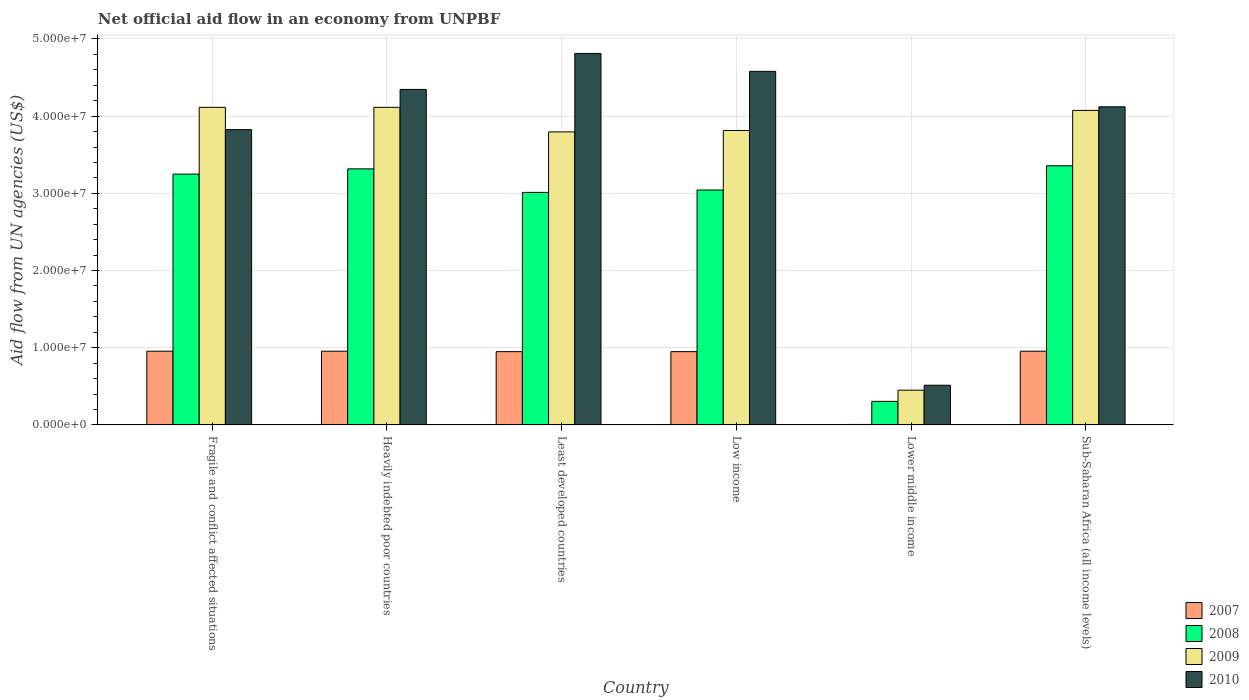How many groups of bars are there?
Your answer should be compact. 6. How many bars are there on the 1st tick from the left?
Make the answer very short. 4. How many bars are there on the 2nd tick from the right?
Your response must be concise. 4. What is the label of the 6th group of bars from the left?
Provide a short and direct response. Sub-Saharan Africa (all income levels). In how many cases, is the number of bars for a given country not equal to the number of legend labels?
Give a very brief answer. 0. What is the net official aid flow in 2009 in Sub-Saharan Africa (all income levels)?
Make the answer very short. 4.07e+07. Across all countries, what is the maximum net official aid flow in 2008?
Make the answer very short. 3.36e+07. Across all countries, what is the minimum net official aid flow in 2010?
Your response must be concise. 5.14e+06. In which country was the net official aid flow in 2010 maximum?
Ensure brevity in your answer.  Least developed countries. In which country was the net official aid flow in 2010 minimum?
Ensure brevity in your answer.  Lower middle income. What is the total net official aid flow in 2007 in the graph?
Offer a terse response. 4.77e+07. What is the difference between the net official aid flow in 2010 in Fragile and conflict affected situations and that in Sub-Saharan Africa (all income levels)?
Keep it short and to the point. -2.96e+06. What is the difference between the net official aid flow in 2009 in Low income and the net official aid flow in 2008 in Heavily indebted poor countries?
Provide a short and direct response. 4.97e+06. What is the average net official aid flow in 2008 per country?
Offer a very short reply. 2.71e+07. What is the difference between the net official aid flow of/in 2008 and net official aid flow of/in 2009 in Low income?
Keep it short and to the point. -7.71e+06. In how many countries, is the net official aid flow in 2008 greater than 38000000 US$?
Provide a succinct answer. 0. What is the ratio of the net official aid flow in 2009 in Least developed countries to that in Sub-Saharan Africa (all income levels)?
Keep it short and to the point. 0.93. Is the net official aid flow in 2008 in Least developed countries less than that in Sub-Saharan Africa (all income levels)?
Provide a short and direct response. Yes. What is the difference between the highest and the second highest net official aid flow in 2009?
Provide a short and direct response. 4.00e+05. What is the difference between the highest and the lowest net official aid flow in 2008?
Offer a terse response. 3.05e+07. In how many countries, is the net official aid flow in 2008 greater than the average net official aid flow in 2008 taken over all countries?
Ensure brevity in your answer.  5. Is the sum of the net official aid flow in 2007 in Low income and Sub-Saharan Africa (all income levels) greater than the maximum net official aid flow in 2010 across all countries?
Make the answer very short. No. Is it the case that in every country, the sum of the net official aid flow in 2008 and net official aid flow in 2007 is greater than the sum of net official aid flow in 2009 and net official aid flow in 2010?
Keep it short and to the point. No. What does the 1st bar from the left in Sub-Saharan Africa (all income levels) represents?
Give a very brief answer. 2007. Is it the case that in every country, the sum of the net official aid flow in 2010 and net official aid flow in 2007 is greater than the net official aid flow in 2008?
Keep it short and to the point. Yes. How many bars are there?
Make the answer very short. 24. What is the difference between two consecutive major ticks on the Y-axis?
Offer a very short reply. 1.00e+07. Are the values on the major ticks of Y-axis written in scientific E-notation?
Give a very brief answer. Yes. How many legend labels are there?
Give a very brief answer. 4. What is the title of the graph?
Make the answer very short. Net official aid flow in an economy from UNPBF. Does "1994" appear as one of the legend labels in the graph?
Keep it short and to the point. No. What is the label or title of the X-axis?
Your answer should be compact. Country. What is the label or title of the Y-axis?
Ensure brevity in your answer.  Aid flow from UN agencies (US$). What is the Aid flow from UN agencies (US$) of 2007 in Fragile and conflict affected situations?
Your response must be concise. 9.55e+06. What is the Aid flow from UN agencies (US$) of 2008 in Fragile and conflict affected situations?
Keep it short and to the point. 3.25e+07. What is the Aid flow from UN agencies (US$) of 2009 in Fragile and conflict affected situations?
Provide a short and direct response. 4.11e+07. What is the Aid flow from UN agencies (US$) in 2010 in Fragile and conflict affected situations?
Offer a terse response. 3.82e+07. What is the Aid flow from UN agencies (US$) of 2007 in Heavily indebted poor countries?
Offer a very short reply. 9.55e+06. What is the Aid flow from UN agencies (US$) in 2008 in Heavily indebted poor countries?
Offer a terse response. 3.32e+07. What is the Aid flow from UN agencies (US$) in 2009 in Heavily indebted poor countries?
Offer a terse response. 4.11e+07. What is the Aid flow from UN agencies (US$) of 2010 in Heavily indebted poor countries?
Keep it short and to the point. 4.35e+07. What is the Aid flow from UN agencies (US$) of 2007 in Least developed countries?
Offer a terse response. 9.49e+06. What is the Aid flow from UN agencies (US$) of 2008 in Least developed countries?
Your answer should be very brief. 3.01e+07. What is the Aid flow from UN agencies (US$) of 2009 in Least developed countries?
Keep it short and to the point. 3.80e+07. What is the Aid flow from UN agencies (US$) in 2010 in Least developed countries?
Your answer should be very brief. 4.81e+07. What is the Aid flow from UN agencies (US$) of 2007 in Low income?
Your answer should be compact. 9.49e+06. What is the Aid flow from UN agencies (US$) in 2008 in Low income?
Offer a very short reply. 3.04e+07. What is the Aid flow from UN agencies (US$) in 2009 in Low income?
Ensure brevity in your answer.  3.81e+07. What is the Aid flow from UN agencies (US$) in 2010 in Low income?
Give a very brief answer. 4.58e+07. What is the Aid flow from UN agencies (US$) in 2008 in Lower middle income?
Your answer should be compact. 3.05e+06. What is the Aid flow from UN agencies (US$) in 2009 in Lower middle income?
Provide a succinct answer. 4.50e+06. What is the Aid flow from UN agencies (US$) in 2010 in Lower middle income?
Offer a very short reply. 5.14e+06. What is the Aid flow from UN agencies (US$) of 2007 in Sub-Saharan Africa (all income levels)?
Your answer should be very brief. 9.55e+06. What is the Aid flow from UN agencies (US$) of 2008 in Sub-Saharan Africa (all income levels)?
Offer a very short reply. 3.36e+07. What is the Aid flow from UN agencies (US$) of 2009 in Sub-Saharan Africa (all income levels)?
Your answer should be very brief. 4.07e+07. What is the Aid flow from UN agencies (US$) in 2010 in Sub-Saharan Africa (all income levels)?
Provide a short and direct response. 4.12e+07. Across all countries, what is the maximum Aid flow from UN agencies (US$) in 2007?
Your response must be concise. 9.55e+06. Across all countries, what is the maximum Aid flow from UN agencies (US$) in 2008?
Offer a very short reply. 3.36e+07. Across all countries, what is the maximum Aid flow from UN agencies (US$) of 2009?
Offer a terse response. 4.11e+07. Across all countries, what is the maximum Aid flow from UN agencies (US$) of 2010?
Keep it short and to the point. 4.81e+07. Across all countries, what is the minimum Aid flow from UN agencies (US$) in 2008?
Keep it short and to the point. 3.05e+06. Across all countries, what is the minimum Aid flow from UN agencies (US$) of 2009?
Provide a succinct answer. 4.50e+06. Across all countries, what is the minimum Aid flow from UN agencies (US$) of 2010?
Keep it short and to the point. 5.14e+06. What is the total Aid flow from UN agencies (US$) in 2007 in the graph?
Your response must be concise. 4.77e+07. What is the total Aid flow from UN agencies (US$) of 2008 in the graph?
Ensure brevity in your answer.  1.63e+08. What is the total Aid flow from UN agencies (US$) of 2009 in the graph?
Your answer should be very brief. 2.04e+08. What is the total Aid flow from UN agencies (US$) in 2010 in the graph?
Your answer should be very brief. 2.22e+08. What is the difference between the Aid flow from UN agencies (US$) in 2007 in Fragile and conflict affected situations and that in Heavily indebted poor countries?
Your response must be concise. 0. What is the difference between the Aid flow from UN agencies (US$) in 2008 in Fragile and conflict affected situations and that in Heavily indebted poor countries?
Offer a very short reply. -6.80e+05. What is the difference between the Aid flow from UN agencies (US$) of 2009 in Fragile and conflict affected situations and that in Heavily indebted poor countries?
Ensure brevity in your answer.  0. What is the difference between the Aid flow from UN agencies (US$) in 2010 in Fragile and conflict affected situations and that in Heavily indebted poor countries?
Your answer should be very brief. -5.21e+06. What is the difference between the Aid flow from UN agencies (US$) in 2007 in Fragile and conflict affected situations and that in Least developed countries?
Ensure brevity in your answer.  6.00e+04. What is the difference between the Aid flow from UN agencies (US$) of 2008 in Fragile and conflict affected situations and that in Least developed countries?
Offer a very short reply. 2.37e+06. What is the difference between the Aid flow from UN agencies (US$) of 2009 in Fragile and conflict affected situations and that in Least developed countries?
Your answer should be very brief. 3.18e+06. What is the difference between the Aid flow from UN agencies (US$) in 2010 in Fragile and conflict affected situations and that in Least developed countries?
Offer a terse response. -9.87e+06. What is the difference between the Aid flow from UN agencies (US$) in 2008 in Fragile and conflict affected situations and that in Low income?
Your answer should be compact. 2.06e+06. What is the difference between the Aid flow from UN agencies (US$) of 2010 in Fragile and conflict affected situations and that in Low income?
Give a very brief answer. -7.55e+06. What is the difference between the Aid flow from UN agencies (US$) of 2007 in Fragile and conflict affected situations and that in Lower middle income?
Ensure brevity in your answer.  9.49e+06. What is the difference between the Aid flow from UN agencies (US$) in 2008 in Fragile and conflict affected situations and that in Lower middle income?
Make the answer very short. 2.94e+07. What is the difference between the Aid flow from UN agencies (US$) in 2009 in Fragile and conflict affected situations and that in Lower middle income?
Make the answer very short. 3.66e+07. What is the difference between the Aid flow from UN agencies (US$) in 2010 in Fragile and conflict affected situations and that in Lower middle income?
Provide a short and direct response. 3.31e+07. What is the difference between the Aid flow from UN agencies (US$) in 2008 in Fragile and conflict affected situations and that in Sub-Saharan Africa (all income levels)?
Offer a terse response. -1.08e+06. What is the difference between the Aid flow from UN agencies (US$) of 2009 in Fragile and conflict affected situations and that in Sub-Saharan Africa (all income levels)?
Offer a terse response. 4.00e+05. What is the difference between the Aid flow from UN agencies (US$) in 2010 in Fragile and conflict affected situations and that in Sub-Saharan Africa (all income levels)?
Offer a very short reply. -2.96e+06. What is the difference between the Aid flow from UN agencies (US$) in 2007 in Heavily indebted poor countries and that in Least developed countries?
Keep it short and to the point. 6.00e+04. What is the difference between the Aid flow from UN agencies (US$) of 2008 in Heavily indebted poor countries and that in Least developed countries?
Give a very brief answer. 3.05e+06. What is the difference between the Aid flow from UN agencies (US$) of 2009 in Heavily indebted poor countries and that in Least developed countries?
Ensure brevity in your answer.  3.18e+06. What is the difference between the Aid flow from UN agencies (US$) of 2010 in Heavily indebted poor countries and that in Least developed countries?
Make the answer very short. -4.66e+06. What is the difference between the Aid flow from UN agencies (US$) in 2007 in Heavily indebted poor countries and that in Low income?
Your answer should be compact. 6.00e+04. What is the difference between the Aid flow from UN agencies (US$) of 2008 in Heavily indebted poor countries and that in Low income?
Make the answer very short. 2.74e+06. What is the difference between the Aid flow from UN agencies (US$) of 2009 in Heavily indebted poor countries and that in Low income?
Your answer should be compact. 3.00e+06. What is the difference between the Aid flow from UN agencies (US$) in 2010 in Heavily indebted poor countries and that in Low income?
Provide a succinct answer. -2.34e+06. What is the difference between the Aid flow from UN agencies (US$) of 2007 in Heavily indebted poor countries and that in Lower middle income?
Your response must be concise. 9.49e+06. What is the difference between the Aid flow from UN agencies (US$) in 2008 in Heavily indebted poor countries and that in Lower middle income?
Offer a terse response. 3.01e+07. What is the difference between the Aid flow from UN agencies (US$) of 2009 in Heavily indebted poor countries and that in Lower middle income?
Keep it short and to the point. 3.66e+07. What is the difference between the Aid flow from UN agencies (US$) in 2010 in Heavily indebted poor countries and that in Lower middle income?
Provide a short and direct response. 3.83e+07. What is the difference between the Aid flow from UN agencies (US$) in 2007 in Heavily indebted poor countries and that in Sub-Saharan Africa (all income levels)?
Keep it short and to the point. 0. What is the difference between the Aid flow from UN agencies (US$) of 2008 in Heavily indebted poor countries and that in Sub-Saharan Africa (all income levels)?
Provide a succinct answer. -4.00e+05. What is the difference between the Aid flow from UN agencies (US$) of 2009 in Heavily indebted poor countries and that in Sub-Saharan Africa (all income levels)?
Give a very brief answer. 4.00e+05. What is the difference between the Aid flow from UN agencies (US$) of 2010 in Heavily indebted poor countries and that in Sub-Saharan Africa (all income levels)?
Ensure brevity in your answer.  2.25e+06. What is the difference between the Aid flow from UN agencies (US$) in 2007 in Least developed countries and that in Low income?
Give a very brief answer. 0. What is the difference between the Aid flow from UN agencies (US$) of 2008 in Least developed countries and that in Low income?
Make the answer very short. -3.10e+05. What is the difference between the Aid flow from UN agencies (US$) of 2010 in Least developed countries and that in Low income?
Offer a very short reply. 2.32e+06. What is the difference between the Aid flow from UN agencies (US$) of 2007 in Least developed countries and that in Lower middle income?
Your answer should be very brief. 9.43e+06. What is the difference between the Aid flow from UN agencies (US$) in 2008 in Least developed countries and that in Lower middle income?
Your answer should be compact. 2.71e+07. What is the difference between the Aid flow from UN agencies (US$) of 2009 in Least developed countries and that in Lower middle income?
Give a very brief answer. 3.35e+07. What is the difference between the Aid flow from UN agencies (US$) in 2010 in Least developed countries and that in Lower middle income?
Offer a terse response. 4.30e+07. What is the difference between the Aid flow from UN agencies (US$) in 2007 in Least developed countries and that in Sub-Saharan Africa (all income levels)?
Provide a short and direct response. -6.00e+04. What is the difference between the Aid flow from UN agencies (US$) of 2008 in Least developed countries and that in Sub-Saharan Africa (all income levels)?
Provide a short and direct response. -3.45e+06. What is the difference between the Aid flow from UN agencies (US$) of 2009 in Least developed countries and that in Sub-Saharan Africa (all income levels)?
Offer a very short reply. -2.78e+06. What is the difference between the Aid flow from UN agencies (US$) of 2010 in Least developed countries and that in Sub-Saharan Africa (all income levels)?
Provide a succinct answer. 6.91e+06. What is the difference between the Aid flow from UN agencies (US$) in 2007 in Low income and that in Lower middle income?
Offer a very short reply. 9.43e+06. What is the difference between the Aid flow from UN agencies (US$) of 2008 in Low income and that in Lower middle income?
Your response must be concise. 2.74e+07. What is the difference between the Aid flow from UN agencies (US$) in 2009 in Low income and that in Lower middle income?
Keep it short and to the point. 3.36e+07. What is the difference between the Aid flow from UN agencies (US$) in 2010 in Low income and that in Lower middle income?
Make the answer very short. 4.07e+07. What is the difference between the Aid flow from UN agencies (US$) of 2007 in Low income and that in Sub-Saharan Africa (all income levels)?
Provide a short and direct response. -6.00e+04. What is the difference between the Aid flow from UN agencies (US$) in 2008 in Low income and that in Sub-Saharan Africa (all income levels)?
Offer a very short reply. -3.14e+06. What is the difference between the Aid flow from UN agencies (US$) in 2009 in Low income and that in Sub-Saharan Africa (all income levels)?
Your response must be concise. -2.60e+06. What is the difference between the Aid flow from UN agencies (US$) in 2010 in Low income and that in Sub-Saharan Africa (all income levels)?
Offer a very short reply. 4.59e+06. What is the difference between the Aid flow from UN agencies (US$) in 2007 in Lower middle income and that in Sub-Saharan Africa (all income levels)?
Make the answer very short. -9.49e+06. What is the difference between the Aid flow from UN agencies (US$) in 2008 in Lower middle income and that in Sub-Saharan Africa (all income levels)?
Give a very brief answer. -3.05e+07. What is the difference between the Aid flow from UN agencies (US$) of 2009 in Lower middle income and that in Sub-Saharan Africa (all income levels)?
Keep it short and to the point. -3.62e+07. What is the difference between the Aid flow from UN agencies (US$) in 2010 in Lower middle income and that in Sub-Saharan Africa (all income levels)?
Keep it short and to the point. -3.61e+07. What is the difference between the Aid flow from UN agencies (US$) of 2007 in Fragile and conflict affected situations and the Aid flow from UN agencies (US$) of 2008 in Heavily indebted poor countries?
Ensure brevity in your answer.  -2.36e+07. What is the difference between the Aid flow from UN agencies (US$) in 2007 in Fragile and conflict affected situations and the Aid flow from UN agencies (US$) in 2009 in Heavily indebted poor countries?
Your response must be concise. -3.16e+07. What is the difference between the Aid flow from UN agencies (US$) of 2007 in Fragile and conflict affected situations and the Aid flow from UN agencies (US$) of 2010 in Heavily indebted poor countries?
Give a very brief answer. -3.39e+07. What is the difference between the Aid flow from UN agencies (US$) of 2008 in Fragile and conflict affected situations and the Aid flow from UN agencies (US$) of 2009 in Heavily indebted poor countries?
Offer a very short reply. -8.65e+06. What is the difference between the Aid flow from UN agencies (US$) in 2008 in Fragile and conflict affected situations and the Aid flow from UN agencies (US$) in 2010 in Heavily indebted poor countries?
Ensure brevity in your answer.  -1.10e+07. What is the difference between the Aid flow from UN agencies (US$) in 2009 in Fragile and conflict affected situations and the Aid flow from UN agencies (US$) in 2010 in Heavily indebted poor countries?
Your response must be concise. -2.32e+06. What is the difference between the Aid flow from UN agencies (US$) in 2007 in Fragile and conflict affected situations and the Aid flow from UN agencies (US$) in 2008 in Least developed countries?
Your answer should be compact. -2.06e+07. What is the difference between the Aid flow from UN agencies (US$) of 2007 in Fragile and conflict affected situations and the Aid flow from UN agencies (US$) of 2009 in Least developed countries?
Provide a succinct answer. -2.84e+07. What is the difference between the Aid flow from UN agencies (US$) in 2007 in Fragile and conflict affected situations and the Aid flow from UN agencies (US$) in 2010 in Least developed countries?
Give a very brief answer. -3.86e+07. What is the difference between the Aid flow from UN agencies (US$) of 2008 in Fragile and conflict affected situations and the Aid flow from UN agencies (US$) of 2009 in Least developed countries?
Provide a succinct answer. -5.47e+06. What is the difference between the Aid flow from UN agencies (US$) of 2008 in Fragile and conflict affected situations and the Aid flow from UN agencies (US$) of 2010 in Least developed countries?
Offer a terse response. -1.56e+07. What is the difference between the Aid flow from UN agencies (US$) of 2009 in Fragile and conflict affected situations and the Aid flow from UN agencies (US$) of 2010 in Least developed countries?
Your answer should be very brief. -6.98e+06. What is the difference between the Aid flow from UN agencies (US$) in 2007 in Fragile and conflict affected situations and the Aid flow from UN agencies (US$) in 2008 in Low income?
Your response must be concise. -2.09e+07. What is the difference between the Aid flow from UN agencies (US$) in 2007 in Fragile and conflict affected situations and the Aid flow from UN agencies (US$) in 2009 in Low income?
Ensure brevity in your answer.  -2.86e+07. What is the difference between the Aid flow from UN agencies (US$) in 2007 in Fragile and conflict affected situations and the Aid flow from UN agencies (US$) in 2010 in Low income?
Your response must be concise. -3.62e+07. What is the difference between the Aid flow from UN agencies (US$) of 2008 in Fragile and conflict affected situations and the Aid flow from UN agencies (US$) of 2009 in Low income?
Ensure brevity in your answer.  -5.65e+06. What is the difference between the Aid flow from UN agencies (US$) in 2008 in Fragile and conflict affected situations and the Aid flow from UN agencies (US$) in 2010 in Low income?
Offer a very short reply. -1.33e+07. What is the difference between the Aid flow from UN agencies (US$) of 2009 in Fragile and conflict affected situations and the Aid flow from UN agencies (US$) of 2010 in Low income?
Make the answer very short. -4.66e+06. What is the difference between the Aid flow from UN agencies (US$) of 2007 in Fragile and conflict affected situations and the Aid flow from UN agencies (US$) of 2008 in Lower middle income?
Provide a succinct answer. 6.50e+06. What is the difference between the Aid flow from UN agencies (US$) in 2007 in Fragile and conflict affected situations and the Aid flow from UN agencies (US$) in 2009 in Lower middle income?
Your response must be concise. 5.05e+06. What is the difference between the Aid flow from UN agencies (US$) in 2007 in Fragile and conflict affected situations and the Aid flow from UN agencies (US$) in 2010 in Lower middle income?
Offer a very short reply. 4.41e+06. What is the difference between the Aid flow from UN agencies (US$) in 2008 in Fragile and conflict affected situations and the Aid flow from UN agencies (US$) in 2009 in Lower middle income?
Give a very brief answer. 2.80e+07. What is the difference between the Aid flow from UN agencies (US$) of 2008 in Fragile and conflict affected situations and the Aid flow from UN agencies (US$) of 2010 in Lower middle income?
Offer a terse response. 2.74e+07. What is the difference between the Aid flow from UN agencies (US$) of 2009 in Fragile and conflict affected situations and the Aid flow from UN agencies (US$) of 2010 in Lower middle income?
Ensure brevity in your answer.  3.60e+07. What is the difference between the Aid flow from UN agencies (US$) in 2007 in Fragile and conflict affected situations and the Aid flow from UN agencies (US$) in 2008 in Sub-Saharan Africa (all income levels)?
Your answer should be compact. -2.40e+07. What is the difference between the Aid flow from UN agencies (US$) of 2007 in Fragile and conflict affected situations and the Aid flow from UN agencies (US$) of 2009 in Sub-Saharan Africa (all income levels)?
Provide a succinct answer. -3.12e+07. What is the difference between the Aid flow from UN agencies (US$) of 2007 in Fragile and conflict affected situations and the Aid flow from UN agencies (US$) of 2010 in Sub-Saharan Africa (all income levels)?
Provide a short and direct response. -3.17e+07. What is the difference between the Aid flow from UN agencies (US$) in 2008 in Fragile and conflict affected situations and the Aid flow from UN agencies (US$) in 2009 in Sub-Saharan Africa (all income levels)?
Offer a very short reply. -8.25e+06. What is the difference between the Aid flow from UN agencies (US$) of 2008 in Fragile and conflict affected situations and the Aid flow from UN agencies (US$) of 2010 in Sub-Saharan Africa (all income levels)?
Your answer should be compact. -8.72e+06. What is the difference between the Aid flow from UN agencies (US$) of 2007 in Heavily indebted poor countries and the Aid flow from UN agencies (US$) of 2008 in Least developed countries?
Your response must be concise. -2.06e+07. What is the difference between the Aid flow from UN agencies (US$) in 2007 in Heavily indebted poor countries and the Aid flow from UN agencies (US$) in 2009 in Least developed countries?
Your answer should be very brief. -2.84e+07. What is the difference between the Aid flow from UN agencies (US$) of 2007 in Heavily indebted poor countries and the Aid flow from UN agencies (US$) of 2010 in Least developed countries?
Your answer should be compact. -3.86e+07. What is the difference between the Aid flow from UN agencies (US$) of 2008 in Heavily indebted poor countries and the Aid flow from UN agencies (US$) of 2009 in Least developed countries?
Your answer should be very brief. -4.79e+06. What is the difference between the Aid flow from UN agencies (US$) in 2008 in Heavily indebted poor countries and the Aid flow from UN agencies (US$) in 2010 in Least developed countries?
Keep it short and to the point. -1.50e+07. What is the difference between the Aid flow from UN agencies (US$) of 2009 in Heavily indebted poor countries and the Aid flow from UN agencies (US$) of 2010 in Least developed countries?
Keep it short and to the point. -6.98e+06. What is the difference between the Aid flow from UN agencies (US$) of 2007 in Heavily indebted poor countries and the Aid flow from UN agencies (US$) of 2008 in Low income?
Offer a very short reply. -2.09e+07. What is the difference between the Aid flow from UN agencies (US$) of 2007 in Heavily indebted poor countries and the Aid flow from UN agencies (US$) of 2009 in Low income?
Provide a short and direct response. -2.86e+07. What is the difference between the Aid flow from UN agencies (US$) of 2007 in Heavily indebted poor countries and the Aid flow from UN agencies (US$) of 2010 in Low income?
Your answer should be very brief. -3.62e+07. What is the difference between the Aid flow from UN agencies (US$) of 2008 in Heavily indebted poor countries and the Aid flow from UN agencies (US$) of 2009 in Low income?
Your response must be concise. -4.97e+06. What is the difference between the Aid flow from UN agencies (US$) in 2008 in Heavily indebted poor countries and the Aid flow from UN agencies (US$) in 2010 in Low income?
Provide a succinct answer. -1.26e+07. What is the difference between the Aid flow from UN agencies (US$) in 2009 in Heavily indebted poor countries and the Aid flow from UN agencies (US$) in 2010 in Low income?
Ensure brevity in your answer.  -4.66e+06. What is the difference between the Aid flow from UN agencies (US$) in 2007 in Heavily indebted poor countries and the Aid flow from UN agencies (US$) in 2008 in Lower middle income?
Provide a short and direct response. 6.50e+06. What is the difference between the Aid flow from UN agencies (US$) in 2007 in Heavily indebted poor countries and the Aid flow from UN agencies (US$) in 2009 in Lower middle income?
Offer a terse response. 5.05e+06. What is the difference between the Aid flow from UN agencies (US$) in 2007 in Heavily indebted poor countries and the Aid flow from UN agencies (US$) in 2010 in Lower middle income?
Your response must be concise. 4.41e+06. What is the difference between the Aid flow from UN agencies (US$) in 2008 in Heavily indebted poor countries and the Aid flow from UN agencies (US$) in 2009 in Lower middle income?
Keep it short and to the point. 2.87e+07. What is the difference between the Aid flow from UN agencies (US$) in 2008 in Heavily indebted poor countries and the Aid flow from UN agencies (US$) in 2010 in Lower middle income?
Keep it short and to the point. 2.80e+07. What is the difference between the Aid flow from UN agencies (US$) in 2009 in Heavily indebted poor countries and the Aid flow from UN agencies (US$) in 2010 in Lower middle income?
Keep it short and to the point. 3.60e+07. What is the difference between the Aid flow from UN agencies (US$) of 2007 in Heavily indebted poor countries and the Aid flow from UN agencies (US$) of 2008 in Sub-Saharan Africa (all income levels)?
Offer a terse response. -2.40e+07. What is the difference between the Aid flow from UN agencies (US$) in 2007 in Heavily indebted poor countries and the Aid flow from UN agencies (US$) in 2009 in Sub-Saharan Africa (all income levels)?
Your response must be concise. -3.12e+07. What is the difference between the Aid flow from UN agencies (US$) in 2007 in Heavily indebted poor countries and the Aid flow from UN agencies (US$) in 2010 in Sub-Saharan Africa (all income levels)?
Ensure brevity in your answer.  -3.17e+07. What is the difference between the Aid flow from UN agencies (US$) in 2008 in Heavily indebted poor countries and the Aid flow from UN agencies (US$) in 2009 in Sub-Saharan Africa (all income levels)?
Your response must be concise. -7.57e+06. What is the difference between the Aid flow from UN agencies (US$) in 2008 in Heavily indebted poor countries and the Aid flow from UN agencies (US$) in 2010 in Sub-Saharan Africa (all income levels)?
Make the answer very short. -8.04e+06. What is the difference between the Aid flow from UN agencies (US$) in 2007 in Least developed countries and the Aid flow from UN agencies (US$) in 2008 in Low income?
Provide a short and direct response. -2.09e+07. What is the difference between the Aid flow from UN agencies (US$) in 2007 in Least developed countries and the Aid flow from UN agencies (US$) in 2009 in Low income?
Make the answer very short. -2.86e+07. What is the difference between the Aid flow from UN agencies (US$) in 2007 in Least developed countries and the Aid flow from UN agencies (US$) in 2010 in Low income?
Your answer should be very brief. -3.63e+07. What is the difference between the Aid flow from UN agencies (US$) in 2008 in Least developed countries and the Aid flow from UN agencies (US$) in 2009 in Low income?
Give a very brief answer. -8.02e+06. What is the difference between the Aid flow from UN agencies (US$) of 2008 in Least developed countries and the Aid flow from UN agencies (US$) of 2010 in Low income?
Give a very brief answer. -1.57e+07. What is the difference between the Aid flow from UN agencies (US$) in 2009 in Least developed countries and the Aid flow from UN agencies (US$) in 2010 in Low income?
Your answer should be very brief. -7.84e+06. What is the difference between the Aid flow from UN agencies (US$) of 2007 in Least developed countries and the Aid flow from UN agencies (US$) of 2008 in Lower middle income?
Offer a very short reply. 6.44e+06. What is the difference between the Aid flow from UN agencies (US$) in 2007 in Least developed countries and the Aid flow from UN agencies (US$) in 2009 in Lower middle income?
Offer a terse response. 4.99e+06. What is the difference between the Aid flow from UN agencies (US$) of 2007 in Least developed countries and the Aid flow from UN agencies (US$) of 2010 in Lower middle income?
Your answer should be compact. 4.35e+06. What is the difference between the Aid flow from UN agencies (US$) of 2008 in Least developed countries and the Aid flow from UN agencies (US$) of 2009 in Lower middle income?
Your answer should be compact. 2.56e+07. What is the difference between the Aid flow from UN agencies (US$) of 2008 in Least developed countries and the Aid flow from UN agencies (US$) of 2010 in Lower middle income?
Provide a short and direct response. 2.50e+07. What is the difference between the Aid flow from UN agencies (US$) of 2009 in Least developed countries and the Aid flow from UN agencies (US$) of 2010 in Lower middle income?
Your answer should be compact. 3.28e+07. What is the difference between the Aid flow from UN agencies (US$) in 2007 in Least developed countries and the Aid flow from UN agencies (US$) in 2008 in Sub-Saharan Africa (all income levels)?
Provide a succinct answer. -2.41e+07. What is the difference between the Aid flow from UN agencies (US$) of 2007 in Least developed countries and the Aid flow from UN agencies (US$) of 2009 in Sub-Saharan Africa (all income levels)?
Your answer should be very brief. -3.12e+07. What is the difference between the Aid flow from UN agencies (US$) of 2007 in Least developed countries and the Aid flow from UN agencies (US$) of 2010 in Sub-Saharan Africa (all income levels)?
Provide a short and direct response. -3.17e+07. What is the difference between the Aid flow from UN agencies (US$) in 2008 in Least developed countries and the Aid flow from UN agencies (US$) in 2009 in Sub-Saharan Africa (all income levels)?
Keep it short and to the point. -1.06e+07. What is the difference between the Aid flow from UN agencies (US$) in 2008 in Least developed countries and the Aid flow from UN agencies (US$) in 2010 in Sub-Saharan Africa (all income levels)?
Offer a terse response. -1.11e+07. What is the difference between the Aid flow from UN agencies (US$) in 2009 in Least developed countries and the Aid flow from UN agencies (US$) in 2010 in Sub-Saharan Africa (all income levels)?
Offer a terse response. -3.25e+06. What is the difference between the Aid flow from UN agencies (US$) of 2007 in Low income and the Aid flow from UN agencies (US$) of 2008 in Lower middle income?
Provide a short and direct response. 6.44e+06. What is the difference between the Aid flow from UN agencies (US$) in 2007 in Low income and the Aid flow from UN agencies (US$) in 2009 in Lower middle income?
Give a very brief answer. 4.99e+06. What is the difference between the Aid flow from UN agencies (US$) of 2007 in Low income and the Aid flow from UN agencies (US$) of 2010 in Lower middle income?
Offer a very short reply. 4.35e+06. What is the difference between the Aid flow from UN agencies (US$) in 2008 in Low income and the Aid flow from UN agencies (US$) in 2009 in Lower middle income?
Provide a short and direct response. 2.59e+07. What is the difference between the Aid flow from UN agencies (US$) of 2008 in Low income and the Aid flow from UN agencies (US$) of 2010 in Lower middle income?
Your answer should be compact. 2.53e+07. What is the difference between the Aid flow from UN agencies (US$) in 2009 in Low income and the Aid flow from UN agencies (US$) in 2010 in Lower middle income?
Offer a very short reply. 3.30e+07. What is the difference between the Aid flow from UN agencies (US$) of 2007 in Low income and the Aid flow from UN agencies (US$) of 2008 in Sub-Saharan Africa (all income levels)?
Give a very brief answer. -2.41e+07. What is the difference between the Aid flow from UN agencies (US$) in 2007 in Low income and the Aid flow from UN agencies (US$) in 2009 in Sub-Saharan Africa (all income levels)?
Make the answer very short. -3.12e+07. What is the difference between the Aid flow from UN agencies (US$) of 2007 in Low income and the Aid flow from UN agencies (US$) of 2010 in Sub-Saharan Africa (all income levels)?
Provide a short and direct response. -3.17e+07. What is the difference between the Aid flow from UN agencies (US$) of 2008 in Low income and the Aid flow from UN agencies (US$) of 2009 in Sub-Saharan Africa (all income levels)?
Offer a very short reply. -1.03e+07. What is the difference between the Aid flow from UN agencies (US$) of 2008 in Low income and the Aid flow from UN agencies (US$) of 2010 in Sub-Saharan Africa (all income levels)?
Your answer should be compact. -1.08e+07. What is the difference between the Aid flow from UN agencies (US$) in 2009 in Low income and the Aid flow from UN agencies (US$) in 2010 in Sub-Saharan Africa (all income levels)?
Offer a very short reply. -3.07e+06. What is the difference between the Aid flow from UN agencies (US$) in 2007 in Lower middle income and the Aid flow from UN agencies (US$) in 2008 in Sub-Saharan Africa (all income levels)?
Your answer should be compact. -3.35e+07. What is the difference between the Aid flow from UN agencies (US$) in 2007 in Lower middle income and the Aid flow from UN agencies (US$) in 2009 in Sub-Saharan Africa (all income levels)?
Keep it short and to the point. -4.07e+07. What is the difference between the Aid flow from UN agencies (US$) of 2007 in Lower middle income and the Aid flow from UN agencies (US$) of 2010 in Sub-Saharan Africa (all income levels)?
Make the answer very short. -4.12e+07. What is the difference between the Aid flow from UN agencies (US$) in 2008 in Lower middle income and the Aid flow from UN agencies (US$) in 2009 in Sub-Saharan Africa (all income levels)?
Provide a short and direct response. -3.77e+07. What is the difference between the Aid flow from UN agencies (US$) in 2008 in Lower middle income and the Aid flow from UN agencies (US$) in 2010 in Sub-Saharan Africa (all income levels)?
Offer a terse response. -3.82e+07. What is the difference between the Aid flow from UN agencies (US$) in 2009 in Lower middle income and the Aid flow from UN agencies (US$) in 2010 in Sub-Saharan Africa (all income levels)?
Make the answer very short. -3.67e+07. What is the average Aid flow from UN agencies (US$) of 2007 per country?
Keep it short and to the point. 7.95e+06. What is the average Aid flow from UN agencies (US$) in 2008 per country?
Keep it short and to the point. 2.71e+07. What is the average Aid flow from UN agencies (US$) of 2009 per country?
Offer a very short reply. 3.39e+07. What is the average Aid flow from UN agencies (US$) of 2010 per country?
Ensure brevity in your answer.  3.70e+07. What is the difference between the Aid flow from UN agencies (US$) in 2007 and Aid flow from UN agencies (US$) in 2008 in Fragile and conflict affected situations?
Your answer should be very brief. -2.29e+07. What is the difference between the Aid flow from UN agencies (US$) in 2007 and Aid flow from UN agencies (US$) in 2009 in Fragile and conflict affected situations?
Your answer should be very brief. -3.16e+07. What is the difference between the Aid flow from UN agencies (US$) of 2007 and Aid flow from UN agencies (US$) of 2010 in Fragile and conflict affected situations?
Your answer should be very brief. -2.87e+07. What is the difference between the Aid flow from UN agencies (US$) in 2008 and Aid flow from UN agencies (US$) in 2009 in Fragile and conflict affected situations?
Provide a short and direct response. -8.65e+06. What is the difference between the Aid flow from UN agencies (US$) in 2008 and Aid flow from UN agencies (US$) in 2010 in Fragile and conflict affected situations?
Your response must be concise. -5.76e+06. What is the difference between the Aid flow from UN agencies (US$) of 2009 and Aid flow from UN agencies (US$) of 2010 in Fragile and conflict affected situations?
Make the answer very short. 2.89e+06. What is the difference between the Aid flow from UN agencies (US$) in 2007 and Aid flow from UN agencies (US$) in 2008 in Heavily indebted poor countries?
Provide a short and direct response. -2.36e+07. What is the difference between the Aid flow from UN agencies (US$) in 2007 and Aid flow from UN agencies (US$) in 2009 in Heavily indebted poor countries?
Provide a short and direct response. -3.16e+07. What is the difference between the Aid flow from UN agencies (US$) of 2007 and Aid flow from UN agencies (US$) of 2010 in Heavily indebted poor countries?
Your answer should be compact. -3.39e+07. What is the difference between the Aid flow from UN agencies (US$) in 2008 and Aid flow from UN agencies (US$) in 2009 in Heavily indebted poor countries?
Ensure brevity in your answer.  -7.97e+06. What is the difference between the Aid flow from UN agencies (US$) of 2008 and Aid flow from UN agencies (US$) of 2010 in Heavily indebted poor countries?
Provide a short and direct response. -1.03e+07. What is the difference between the Aid flow from UN agencies (US$) of 2009 and Aid flow from UN agencies (US$) of 2010 in Heavily indebted poor countries?
Keep it short and to the point. -2.32e+06. What is the difference between the Aid flow from UN agencies (US$) in 2007 and Aid flow from UN agencies (US$) in 2008 in Least developed countries?
Your answer should be compact. -2.06e+07. What is the difference between the Aid flow from UN agencies (US$) of 2007 and Aid flow from UN agencies (US$) of 2009 in Least developed countries?
Give a very brief answer. -2.85e+07. What is the difference between the Aid flow from UN agencies (US$) of 2007 and Aid flow from UN agencies (US$) of 2010 in Least developed countries?
Your answer should be compact. -3.86e+07. What is the difference between the Aid flow from UN agencies (US$) in 2008 and Aid flow from UN agencies (US$) in 2009 in Least developed countries?
Ensure brevity in your answer.  -7.84e+06. What is the difference between the Aid flow from UN agencies (US$) of 2008 and Aid flow from UN agencies (US$) of 2010 in Least developed countries?
Your answer should be very brief. -1.80e+07. What is the difference between the Aid flow from UN agencies (US$) of 2009 and Aid flow from UN agencies (US$) of 2010 in Least developed countries?
Keep it short and to the point. -1.02e+07. What is the difference between the Aid flow from UN agencies (US$) in 2007 and Aid flow from UN agencies (US$) in 2008 in Low income?
Your answer should be very brief. -2.09e+07. What is the difference between the Aid flow from UN agencies (US$) in 2007 and Aid flow from UN agencies (US$) in 2009 in Low income?
Give a very brief answer. -2.86e+07. What is the difference between the Aid flow from UN agencies (US$) in 2007 and Aid flow from UN agencies (US$) in 2010 in Low income?
Your response must be concise. -3.63e+07. What is the difference between the Aid flow from UN agencies (US$) in 2008 and Aid flow from UN agencies (US$) in 2009 in Low income?
Keep it short and to the point. -7.71e+06. What is the difference between the Aid flow from UN agencies (US$) in 2008 and Aid flow from UN agencies (US$) in 2010 in Low income?
Make the answer very short. -1.54e+07. What is the difference between the Aid flow from UN agencies (US$) in 2009 and Aid flow from UN agencies (US$) in 2010 in Low income?
Provide a succinct answer. -7.66e+06. What is the difference between the Aid flow from UN agencies (US$) of 2007 and Aid flow from UN agencies (US$) of 2008 in Lower middle income?
Your response must be concise. -2.99e+06. What is the difference between the Aid flow from UN agencies (US$) of 2007 and Aid flow from UN agencies (US$) of 2009 in Lower middle income?
Ensure brevity in your answer.  -4.44e+06. What is the difference between the Aid flow from UN agencies (US$) in 2007 and Aid flow from UN agencies (US$) in 2010 in Lower middle income?
Provide a short and direct response. -5.08e+06. What is the difference between the Aid flow from UN agencies (US$) in 2008 and Aid flow from UN agencies (US$) in 2009 in Lower middle income?
Your answer should be very brief. -1.45e+06. What is the difference between the Aid flow from UN agencies (US$) in 2008 and Aid flow from UN agencies (US$) in 2010 in Lower middle income?
Ensure brevity in your answer.  -2.09e+06. What is the difference between the Aid flow from UN agencies (US$) in 2009 and Aid flow from UN agencies (US$) in 2010 in Lower middle income?
Provide a short and direct response. -6.40e+05. What is the difference between the Aid flow from UN agencies (US$) of 2007 and Aid flow from UN agencies (US$) of 2008 in Sub-Saharan Africa (all income levels)?
Provide a succinct answer. -2.40e+07. What is the difference between the Aid flow from UN agencies (US$) in 2007 and Aid flow from UN agencies (US$) in 2009 in Sub-Saharan Africa (all income levels)?
Your answer should be compact. -3.12e+07. What is the difference between the Aid flow from UN agencies (US$) in 2007 and Aid flow from UN agencies (US$) in 2010 in Sub-Saharan Africa (all income levels)?
Keep it short and to the point. -3.17e+07. What is the difference between the Aid flow from UN agencies (US$) in 2008 and Aid flow from UN agencies (US$) in 2009 in Sub-Saharan Africa (all income levels)?
Keep it short and to the point. -7.17e+06. What is the difference between the Aid flow from UN agencies (US$) of 2008 and Aid flow from UN agencies (US$) of 2010 in Sub-Saharan Africa (all income levels)?
Offer a terse response. -7.64e+06. What is the difference between the Aid flow from UN agencies (US$) of 2009 and Aid flow from UN agencies (US$) of 2010 in Sub-Saharan Africa (all income levels)?
Offer a terse response. -4.70e+05. What is the ratio of the Aid flow from UN agencies (US$) in 2007 in Fragile and conflict affected situations to that in Heavily indebted poor countries?
Provide a succinct answer. 1. What is the ratio of the Aid flow from UN agencies (US$) in 2008 in Fragile and conflict affected situations to that in Heavily indebted poor countries?
Make the answer very short. 0.98. What is the ratio of the Aid flow from UN agencies (US$) of 2010 in Fragile and conflict affected situations to that in Heavily indebted poor countries?
Make the answer very short. 0.88. What is the ratio of the Aid flow from UN agencies (US$) in 2007 in Fragile and conflict affected situations to that in Least developed countries?
Provide a short and direct response. 1.01. What is the ratio of the Aid flow from UN agencies (US$) in 2008 in Fragile and conflict affected situations to that in Least developed countries?
Ensure brevity in your answer.  1.08. What is the ratio of the Aid flow from UN agencies (US$) of 2009 in Fragile and conflict affected situations to that in Least developed countries?
Ensure brevity in your answer.  1.08. What is the ratio of the Aid flow from UN agencies (US$) in 2010 in Fragile and conflict affected situations to that in Least developed countries?
Give a very brief answer. 0.79. What is the ratio of the Aid flow from UN agencies (US$) in 2008 in Fragile and conflict affected situations to that in Low income?
Provide a short and direct response. 1.07. What is the ratio of the Aid flow from UN agencies (US$) of 2009 in Fragile and conflict affected situations to that in Low income?
Keep it short and to the point. 1.08. What is the ratio of the Aid flow from UN agencies (US$) of 2010 in Fragile and conflict affected situations to that in Low income?
Give a very brief answer. 0.84. What is the ratio of the Aid flow from UN agencies (US$) in 2007 in Fragile and conflict affected situations to that in Lower middle income?
Keep it short and to the point. 159.17. What is the ratio of the Aid flow from UN agencies (US$) of 2008 in Fragile and conflict affected situations to that in Lower middle income?
Make the answer very short. 10.65. What is the ratio of the Aid flow from UN agencies (US$) in 2009 in Fragile and conflict affected situations to that in Lower middle income?
Offer a very short reply. 9.14. What is the ratio of the Aid flow from UN agencies (US$) of 2010 in Fragile and conflict affected situations to that in Lower middle income?
Give a very brief answer. 7.44. What is the ratio of the Aid flow from UN agencies (US$) in 2008 in Fragile and conflict affected situations to that in Sub-Saharan Africa (all income levels)?
Keep it short and to the point. 0.97. What is the ratio of the Aid flow from UN agencies (US$) in 2009 in Fragile and conflict affected situations to that in Sub-Saharan Africa (all income levels)?
Provide a succinct answer. 1.01. What is the ratio of the Aid flow from UN agencies (US$) of 2010 in Fragile and conflict affected situations to that in Sub-Saharan Africa (all income levels)?
Your response must be concise. 0.93. What is the ratio of the Aid flow from UN agencies (US$) in 2008 in Heavily indebted poor countries to that in Least developed countries?
Your answer should be very brief. 1.1. What is the ratio of the Aid flow from UN agencies (US$) of 2009 in Heavily indebted poor countries to that in Least developed countries?
Your answer should be very brief. 1.08. What is the ratio of the Aid flow from UN agencies (US$) of 2010 in Heavily indebted poor countries to that in Least developed countries?
Ensure brevity in your answer.  0.9. What is the ratio of the Aid flow from UN agencies (US$) in 2008 in Heavily indebted poor countries to that in Low income?
Ensure brevity in your answer.  1.09. What is the ratio of the Aid flow from UN agencies (US$) in 2009 in Heavily indebted poor countries to that in Low income?
Your answer should be very brief. 1.08. What is the ratio of the Aid flow from UN agencies (US$) in 2010 in Heavily indebted poor countries to that in Low income?
Provide a short and direct response. 0.95. What is the ratio of the Aid flow from UN agencies (US$) in 2007 in Heavily indebted poor countries to that in Lower middle income?
Provide a succinct answer. 159.17. What is the ratio of the Aid flow from UN agencies (US$) of 2008 in Heavily indebted poor countries to that in Lower middle income?
Offer a very short reply. 10.88. What is the ratio of the Aid flow from UN agencies (US$) in 2009 in Heavily indebted poor countries to that in Lower middle income?
Your answer should be very brief. 9.14. What is the ratio of the Aid flow from UN agencies (US$) in 2010 in Heavily indebted poor countries to that in Lower middle income?
Provide a succinct answer. 8.46. What is the ratio of the Aid flow from UN agencies (US$) of 2009 in Heavily indebted poor countries to that in Sub-Saharan Africa (all income levels)?
Make the answer very short. 1.01. What is the ratio of the Aid flow from UN agencies (US$) of 2010 in Heavily indebted poor countries to that in Sub-Saharan Africa (all income levels)?
Ensure brevity in your answer.  1.05. What is the ratio of the Aid flow from UN agencies (US$) of 2007 in Least developed countries to that in Low income?
Provide a short and direct response. 1. What is the ratio of the Aid flow from UN agencies (US$) in 2008 in Least developed countries to that in Low income?
Offer a very short reply. 0.99. What is the ratio of the Aid flow from UN agencies (US$) of 2010 in Least developed countries to that in Low income?
Keep it short and to the point. 1.05. What is the ratio of the Aid flow from UN agencies (US$) of 2007 in Least developed countries to that in Lower middle income?
Provide a short and direct response. 158.17. What is the ratio of the Aid flow from UN agencies (US$) of 2008 in Least developed countries to that in Lower middle income?
Offer a very short reply. 9.88. What is the ratio of the Aid flow from UN agencies (US$) of 2009 in Least developed countries to that in Lower middle income?
Offer a terse response. 8.44. What is the ratio of the Aid flow from UN agencies (US$) of 2010 in Least developed countries to that in Lower middle income?
Offer a very short reply. 9.36. What is the ratio of the Aid flow from UN agencies (US$) of 2007 in Least developed countries to that in Sub-Saharan Africa (all income levels)?
Your response must be concise. 0.99. What is the ratio of the Aid flow from UN agencies (US$) in 2008 in Least developed countries to that in Sub-Saharan Africa (all income levels)?
Ensure brevity in your answer.  0.9. What is the ratio of the Aid flow from UN agencies (US$) in 2009 in Least developed countries to that in Sub-Saharan Africa (all income levels)?
Your response must be concise. 0.93. What is the ratio of the Aid flow from UN agencies (US$) in 2010 in Least developed countries to that in Sub-Saharan Africa (all income levels)?
Provide a short and direct response. 1.17. What is the ratio of the Aid flow from UN agencies (US$) of 2007 in Low income to that in Lower middle income?
Provide a succinct answer. 158.17. What is the ratio of the Aid flow from UN agencies (US$) of 2008 in Low income to that in Lower middle income?
Provide a succinct answer. 9.98. What is the ratio of the Aid flow from UN agencies (US$) in 2009 in Low income to that in Lower middle income?
Provide a short and direct response. 8.48. What is the ratio of the Aid flow from UN agencies (US$) in 2010 in Low income to that in Lower middle income?
Your answer should be very brief. 8.91. What is the ratio of the Aid flow from UN agencies (US$) in 2007 in Low income to that in Sub-Saharan Africa (all income levels)?
Offer a very short reply. 0.99. What is the ratio of the Aid flow from UN agencies (US$) of 2008 in Low income to that in Sub-Saharan Africa (all income levels)?
Ensure brevity in your answer.  0.91. What is the ratio of the Aid flow from UN agencies (US$) of 2009 in Low income to that in Sub-Saharan Africa (all income levels)?
Offer a terse response. 0.94. What is the ratio of the Aid flow from UN agencies (US$) of 2010 in Low income to that in Sub-Saharan Africa (all income levels)?
Your answer should be very brief. 1.11. What is the ratio of the Aid flow from UN agencies (US$) of 2007 in Lower middle income to that in Sub-Saharan Africa (all income levels)?
Offer a very short reply. 0.01. What is the ratio of the Aid flow from UN agencies (US$) of 2008 in Lower middle income to that in Sub-Saharan Africa (all income levels)?
Your response must be concise. 0.09. What is the ratio of the Aid flow from UN agencies (US$) in 2009 in Lower middle income to that in Sub-Saharan Africa (all income levels)?
Ensure brevity in your answer.  0.11. What is the ratio of the Aid flow from UN agencies (US$) in 2010 in Lower middle income to that in Sub-Saharan Africa (all income levels)?
Provide a short and direct response. 0.12. What is the difference between the highest and the second highest Aid flow from UN agencies (US$) in 2007?
Provide a short and direct response. 0. What is the difference between the highest and the second highest Aid flow from UN agencies (US$) in 2009?
Provide a short and direct response. 0. What is the difference between the highest and the second highest Aid flow from UN agencies (US$) in 2010?
Your answer should be very brief. 2.32e+06. What is the difference between the highest and the lowest Aid flow from UN agencies (US$) in 2007?
Offer a terse response. 9.49e+06. What is the difference between the highest and the lowest Aid flow from UN agencies (US$) in 2008?
Make the answer very short. 3.05e+07. What is the difference between the highest and the lowest Aid flow from UN agencies (US$) in 2009?
Your answer should be very brief. 3.66e+07. What is the difference between the highest and the lowest Aid flow from UN agencies (US$) in 2010?
Ensure brevity in your answer.  4.30e+07. 